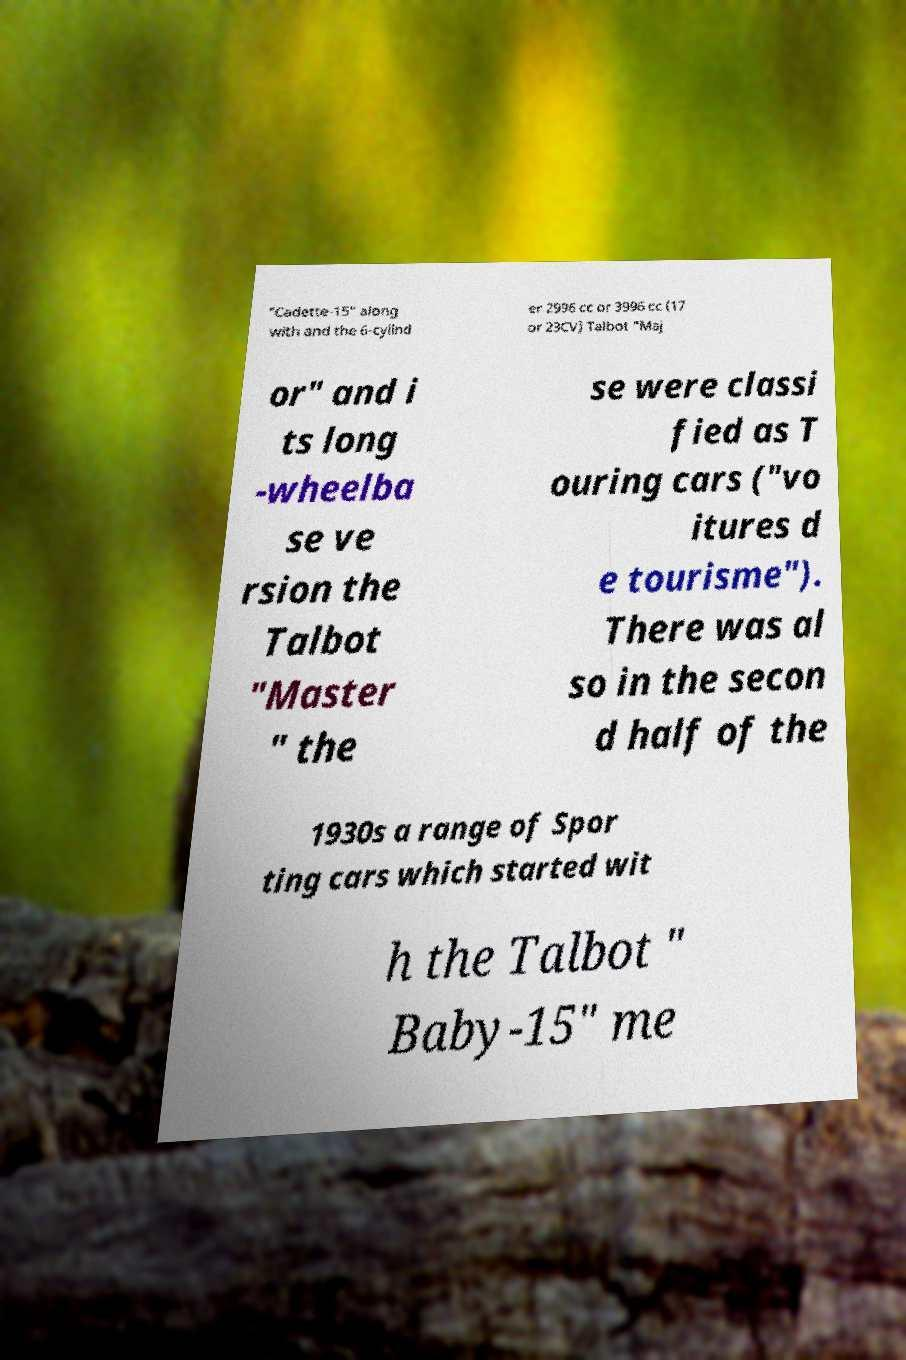Can you accurately transcribe the text from the provided image for me? "Cadette-15" along with and the 6-cylind er 2996 cc or 3996 cc (17 or 23CV) Talbot "Maj or" and i ts long -wheelba se ve rsion the Talbot "Master " the se were classi fied as T ouring cars ("vo itures d e tourisme"). There was al so in the secon d half of the 1930s a range of Spor ting cars which started wit h the Talbot " Baby-15" me 